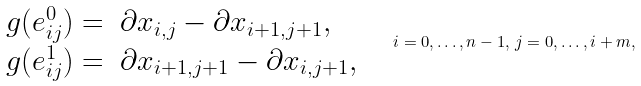Convert formula to latex. <formula><loc_0><loc_0><loc_500><loc_500>\begin{array} { r l } g ( e ^ { 0 } _ { i j } ) = & \partial x _ { i , j } - \partial x _ { i + 1 , j + 1 } , \\ g ( e ^ { 1 } _ { i j } ) = & \partial x _ { i + 1 , j + 1 } - \partial x _ { i , j + 1 } , \end{array} \quad i = 0 , \dots , n - 1 , \, j = 0 , \dots , i + m ,</formula> 